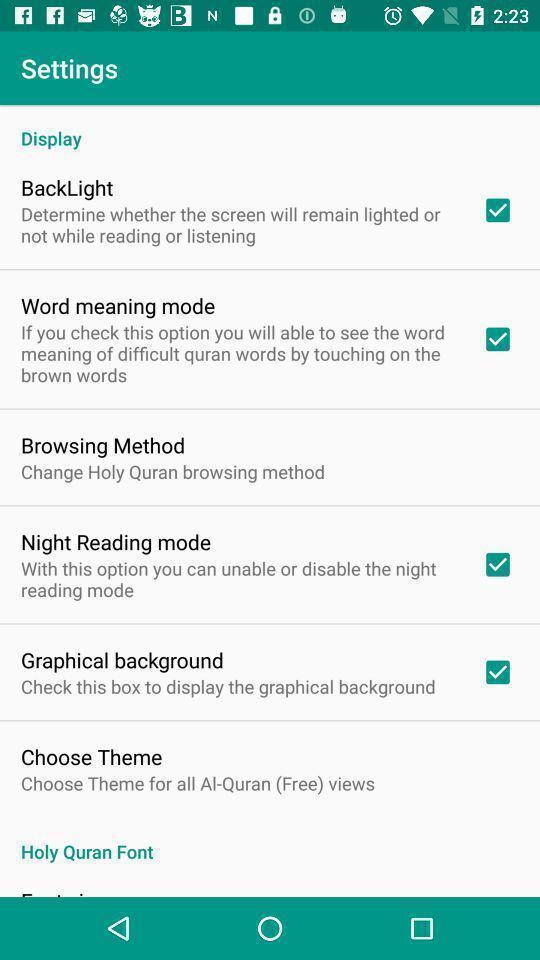Describe the key features of this screenshot. Screen showing settings page. 